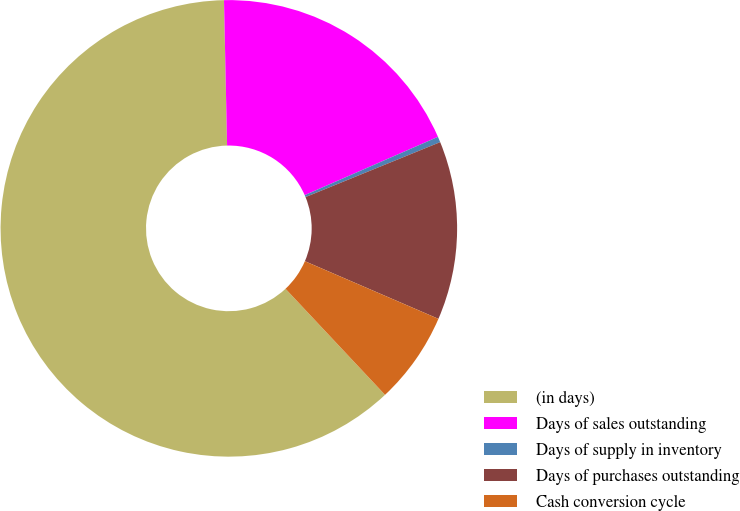<chart> <loc_0><loc_0><loc_500><loc_500><pie_chart><fcel>(in days)<fcel>Days of sales outstanding<fcel>Days of supply in inventory<fcel>Days of purchases outstanding<fcel>Cash conversion cycle<nl><fcel>61.65%<fcel>18.77%<fcel>0.4%<fcel>12.65%<fcel>6.52%<nl></chart> 